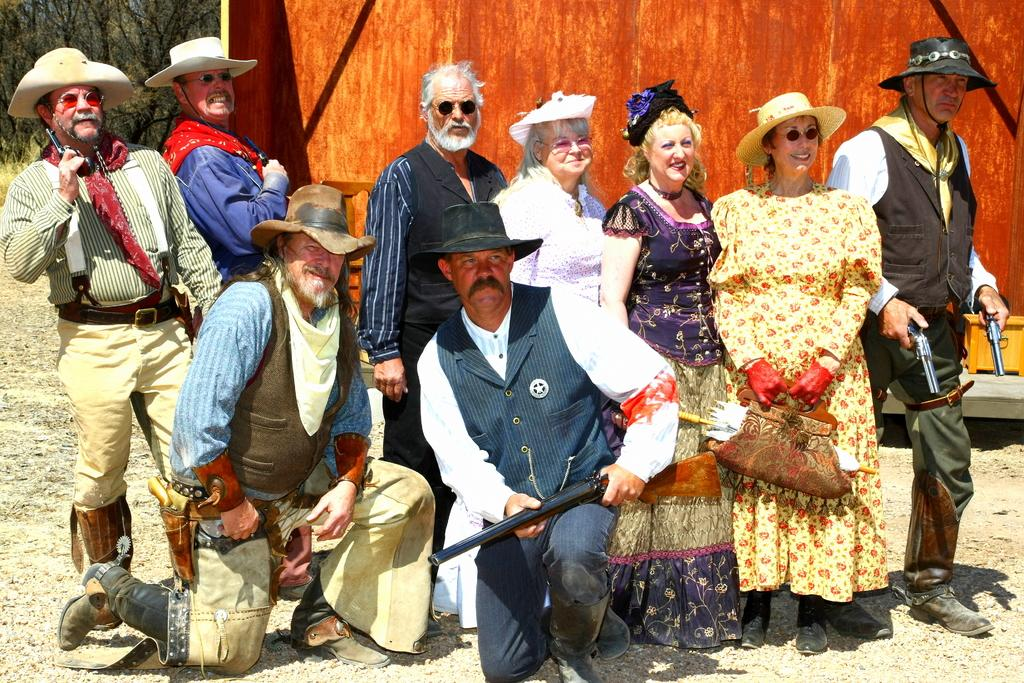Who or what can be seen in the image? There are people in the image. What else is present in the image besides the people? There are other objects in the image. What can be seen in the distance in the image? There is a wall and trees in the background of the image. What is visible at the bottom of the image? The ground is visible at the bottom of the image. What type of fear is being expressed by the people in the image? There is no indication of fear in the image; the people are not expressing any emotions. What kind of feast is being prepared in the image? There is no feast or food preparation visible in the image. 